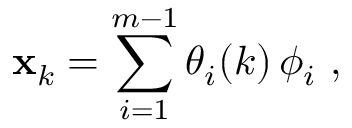<formula> <loc_0><loc_0><loc_500><loc_500>{ x } _ { k } = \sum _ { i = 1 } ^ { m - 1 } \theta _ { i } ( k ) \, \phi _ { i } ,</formula> 